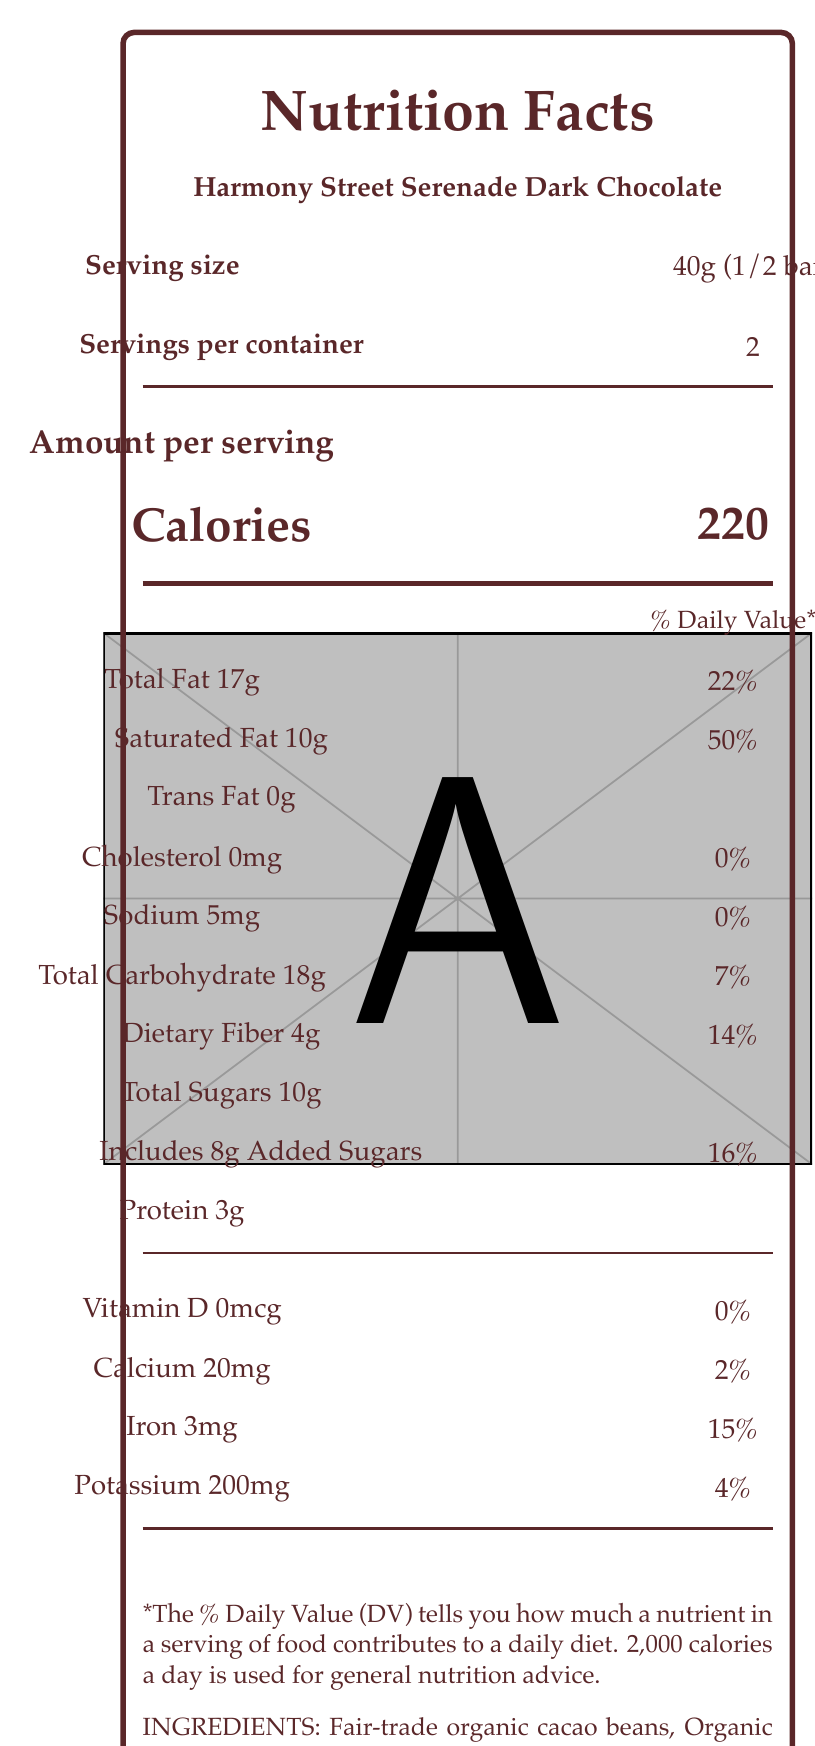what is the serving size? The serving size is specified as "40g (1/2 bar)" in the document.
Answer: 40g (1/2 bar) how many servings are in a container? The document states there are 2 servings per container.
Answer: 2 what is the total fat content per serving? The total fat content per serving is listed as 17g.
Answer: 17g how much dietary fiber is in one serving? The dietary fiber content per serving is 4g.
Answer: 4g what is the percentage of daily value for saturated fat in one serving? The percentage of daily value for saturated fat is 50% per serving.
Answer: 50% how much protein does one serving contain? The protein content per serving is 3g.
Answer: 3g how much calcium is in one serving of the chocolate bar? The amount of calcium per serving is 20mg.
Answer: 20mg what is the origin of the cacao used? The document mentions that the cacao is single-origin from Ecuador.
Answer: Ecuador what certifications does this chocolate bar have? A. USDA Organic B. Fair Trade Certified C. Non-GMO Project Verified D. All of the above The chocolate bar is certified as Fair Trade Certified, USDA Organic, and Non-GMO Project Verified.
Answer: D. All of the above which of the following is NOT an ingredient in this chocolate bar? 1. Fair-trade organic cacao beans 2. Organic cane sugar 3. Milk 4. Organic vanilla beans The document lists "Fair-trade organic cacao beans", "Organic cane sugar", "Organic cocoa butter", and "Organic vanilla beans" as ingredients, and notes that it may contain traces of milk.
Answer: 3. Milk is there any trans fat in this chocolate bar? The document indicates that there is 0g of trans fat in the chocolate bar.
Answer: No describe the main idea of the document. The document is a nutrition facts label for the Harmony Street Serenade Dark Chocolate, covering comprehensive nutritional data, ingredient information, and additional product details.
Answer: The document provides detailed nutrition information for the Harmony Street Serenade Dark Chocolate, a fair-trade, USDA Organic, Non-GMO Project Verified chocolate bar made with minimal additives. This includes information about serving size, calories, and nutrient content per serving. The document also highlights the brand story, ingredient list, certifications, flavor notes, and packaging. how many total grams of sugar does one serving contain? According to the document, total sugars per serving amount to 10g.
Answer: 10g how many added sugars are included in one serving? The document specifies that there are 8g of added sugars per serving.
Answer: 8g what flavor notes are mentioned for this chocolate bar? The flavor notes listed are rich earthy tones, subtle fruit undertones, and a hint of vanilla.
Answer: Rich earthy tones, Subtle fruit undertones, Hint of vanilla what percentage of daily value for potassium is in one serving? The percentage of daily value for potassium listed per serving is 4%.
Answer: 4% who makes Harmony Street Serenade Dark Chocolate? The brand story mentions that the chocolate is crafted by street musicians who believe in the authenticity of both music and chocolate.
Answer: The brand story implies that street musicians craft it. how much sodium is in one serving? A. 20mg B. 30mg C. 5mg D. 10mg The document states that there are 5mg of sodium per serving.
Answer: C. 5mg what is the purpose of the eco-friendly wrapper? The document notes that the packaging is eco-friendly, made from recycled paper and illustrated with musical notes and street scenes.
Answer: It aims to be environmentally conscious and features musical notes and street scenes. what is the cocoa percentage of this chocolate bar? The document lists the cacao percentage as 72%.
Answer: 72% how many total calories are in the entire bar? Since each serving has 220 calories and there are 2 servings per container, the total calories for the entire bar are 220 * 2 = 440 calories.
Answer: 440 calories how much cholesterol is in this chocolate bar? The document lists cholesterol as 0mg per serving, but the question does not specify the total amount in the entire bar, though it can be inferred as 0mg.
Answer: I don't know 